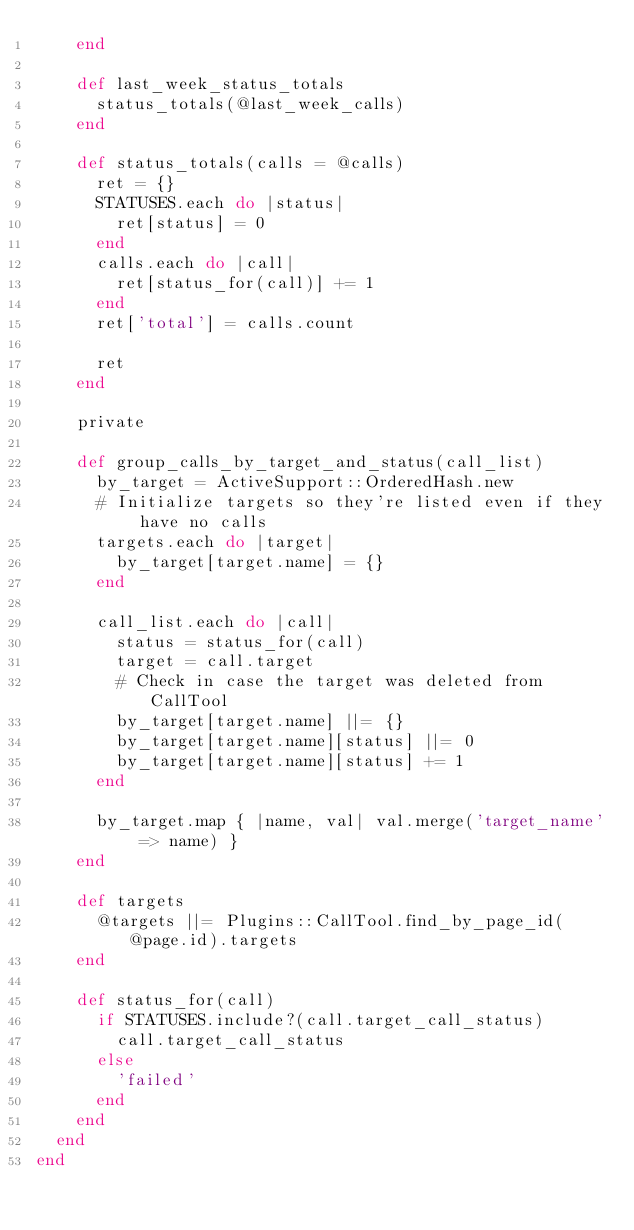<code> <loc_0><loc_0><loc_500><loc_500><_Ruby_>    end

    def last_week_status_totals
      status_totals(@last_week_calls)
    end

    def status_totals(calls = @calls)
      ret = {}
      STATUSES.each do |status|
        ret[status] = 0
      end
      calls.each do |call|
        ret[status_for(call)] += 1
      end
      ret['total'] = calls.count

      ret
    end

    private

    def group_calls_by_target_and_status(call_list)
      by_target = ActiveSupport::OrderedHash.new
      # Initialize targets so they're listed even if they have no calls
      targets.each do |target|
        by_target[target.name] = {}
      end

      call_list.each do |call|
        status = status_for(call)
        target = call.target
        # Check in case the target was deleted from CallTool
        by_target[target.name] ||= {}
        by_target[target.name][status] ||= 0
        by_target[target.name][status] += 1
      end

      by_target.map { |name, val| val.merge('target_name' => name) }
    end

    def targets
      @targets ||= Plugins::CallTool.find_by_page_id(@page.id).targets
    end

    def status_for(call)
      if STATUSES.include?(call.target_call_status)
        call.target_call_status
      else
        'failed'
      end
    end
  end
end
</code> 